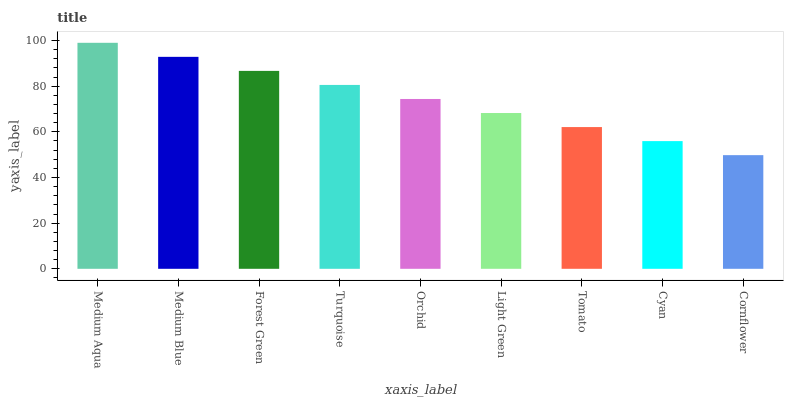Is Cornflower the minimum?
Answer yes or no. Yes. Is Medium Aqua the maximum?
Answer yes or no. Yes. Is Medium Blue the minimum?
Answer yes or no. No. Is Medium Blue the maximum?
Answer yes or no. No. Is Medium Aqua greater than Medium Blue?
Answer yes or no. Yes. Is Medium Blue less than Medium Aqua?
Answer yes or no. Yes. Is Medium Blue greater than Medium Aqua?
Answer yes or no. No. Is Medium Aqua less than Medium Blue?
Answer yes or no. No. Is Orchid the high median?
Answer yes or no. Yes. Is Orchid the low median?
Answer yes or no. Yes. Is Cyan the high median?
Answer yes or no. No. Is Medium Blue the low median?
Answer yes or no. No. 